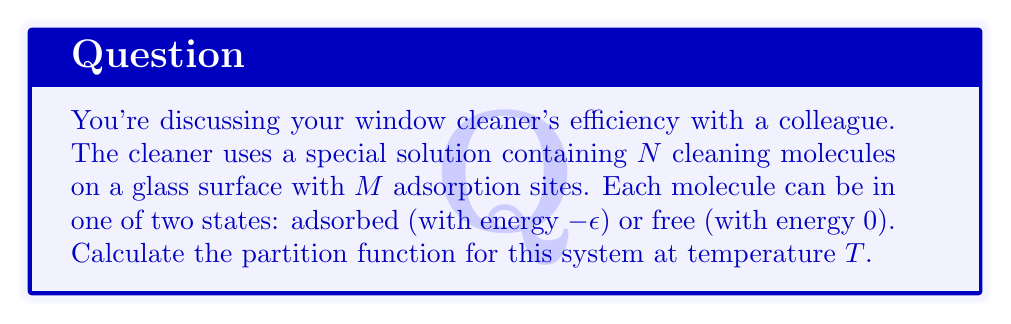Could you help me with this problem? To solve this problem, we'll follow these steps:

1) First, we need to understand what the partition function represents. In statistical mechanics, the partition function $Z$ is the sum over all possible microstates of the system, weighted by their Boltzmann factors.

2) In this case, each cleaning molecule can be in one of two states: adsorbed or free. The number of ways to arrange $n$ adsorbed molecules among $M$ sites is $\binom{M}{n}$.

3) The energy of a microstate with $n$ adsorbed molecules is $-n\epsilon$.

4) The partition function can be written as:

   $$Z = \sum_{n=0}^{\min(N,M)} \binom{M}{n} \binom{N}{n} e^{n\beta\epsilon}$$

   where $\beta = \frac{1}{k_B T}$, $k_B$ is the Boltzmann constant, and $T$ is the temperature.

5) The term $\binom{N}{n}$ accounts for choosing which $n$ out of $N$ molecules are adsorbed.

6) We can simplify this expression using the binomial theorem:

   $$Z = \left(1 + e^{\beta\epsilon}\right)^M$$

   This is because each of the $M$ sites can be either occupied (with a factor of $e^{\beta\epsilon}$) or unoccupied (with a factor of 1).

7) This expression for $Z$ is valid when $N \geq M$. If $N < M$, we would need to use a different approach, considering the limited number of molecules.
Answer: $Z = \left(1 + e^{\beta\epsilon}\right)^M$, where $\beta = \frac{1}{k_B T}$ 